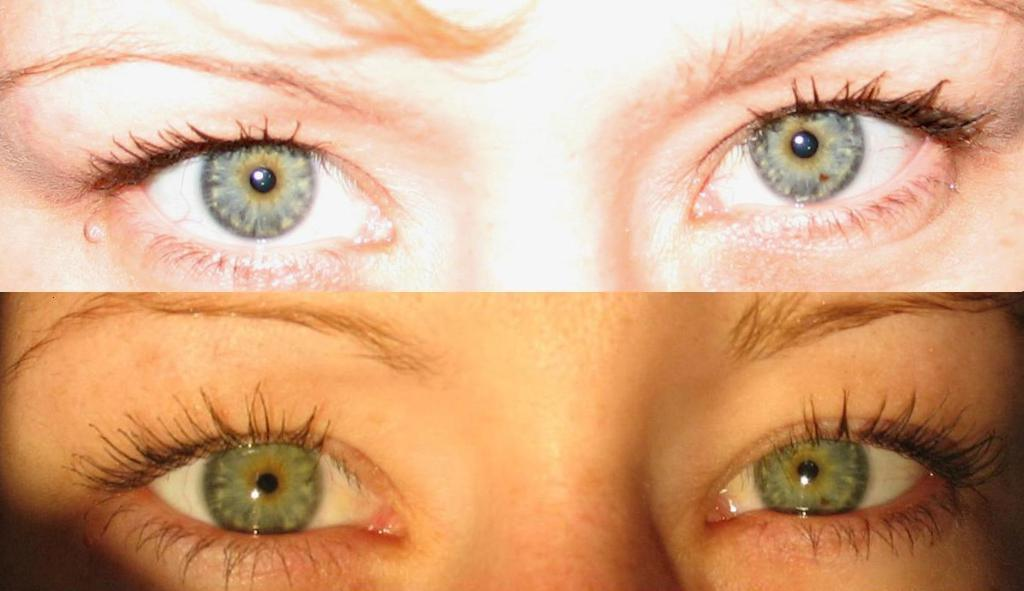What is the main subject of the image? The main subject of the image is two different people's eyes. Can you describe the eyes in the image? There are two different people's eyes in the image, but no other details about their appearance or characteristics are provided. What type of ship is visible in the background of the image? There is no ship present in the image; it only features two different people's eyes. 